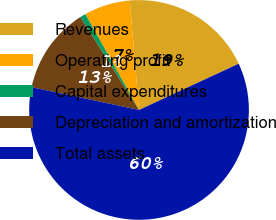Convert chart to OTSL. <chart><loc_0><loc_0><loc_500><loc_500><pie_chart><fcel>Revenues<fcel>Operating profit<fcel>Capital expenditures<fcel>Depreciation and amortization<fcel>Total assets<nl><fcel>19.44%<fcel>6.78%<fcel>0.84%<fcel>12.71%<fcel>60.23%<nl></chart> 